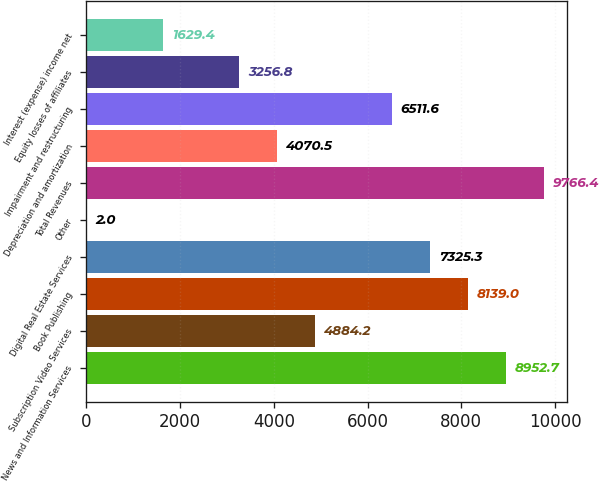Convert chart to OTSL. <chart><loc_0><loc_0><loc_500><loc_500><bar_chart><fcel>News and Information Services<fcel>Subscription Video Services<fcel>Book Publishing<fcel>Digital Real Estate Services<fcel>Other<fcel>Total Revenues<fcel>Depreciation and amortization<fcel>Impairment and restructuring<fcel>Equity losses of affiliates<fcel>Interest (expense) income net<nl><fcel>8952.7<fcel>4884.2<fcel>8139<fcel>7325.3<fcel>2<fcel>9766.4<fcel>4070.5<fcel>6511.6<fcel>3256.8<fcel>1629.4<nl></chart> 